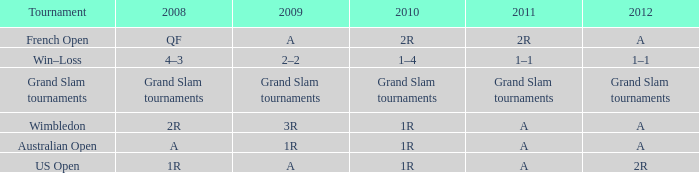Name the 2010 for 2011 of a and 2008 of 1r 1R. 